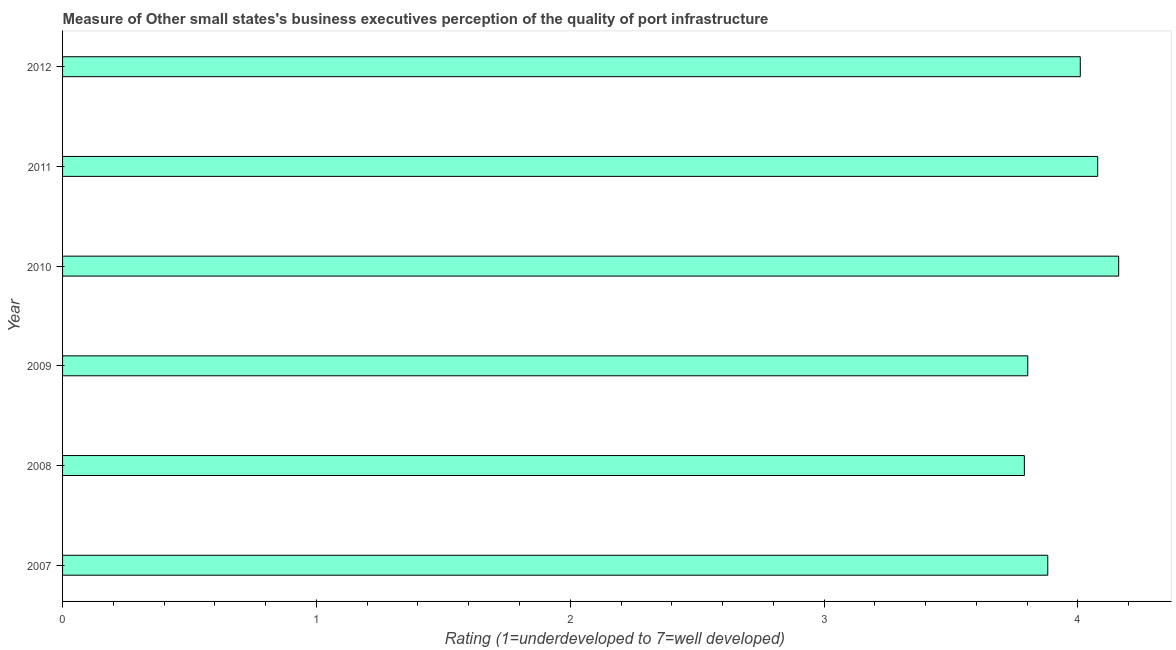What is the title of the graph?
Keep it short and to the point. Measure of Other small states's business executives perception of the quality of port infrastructure. What is the label or title of the X-axis?
Provide a succinct answer. Rating (1=underdeveloped to 7=well developed) . What is the rating measuring quality of port infrastructure in 2010?
Offer a terse response. 4.16. Across all years, what is the maximum rating measuring quality of port infrastructure?
Give a very brief answer. 4.16. Across all years, what is the minimum rating measuring quality of port infrastructure?
Ensure brevity in your answer.  3.79. In which year was the rating measuring quality of port infrastructure maximum?
Offer a very short reply. 2010. What is the sum of the rating measuring quality of port infrastructure?
Ensure brevity in your answer.  23.72. What is the difference between the rating measuring quality of port infrastructure in 2007 and 2012?
Offer a terse response. -0.13. What is the average rating measuring quality of port infrastructure per year?
Give a very brief answer. 3.95. What is the median rating measuring quality of port infrastructure?
Offer a very short reply. 3.95. What is the ratio of the rating measuring quality of port infrastructure in 2009 to that in 2011?
Provide a succinct answer. 0.93. Is the rating measuring quality of port infrastructure in 2010 less than that in 2012?
Ensure brevity in your answer.  No. What is the difference between the highest and the second highest rating measuring quality of port infrastructure?
Keep it short and to the point. 0.08. What is the difference between the highest and the lowest rating measuring quality of port infrastructure?
Give a very brief answer. 0.37. How many bars are there?
Provide a succinct answer. 6. Are all the bars in the graph horizontal?
Provide a short and direct response. Yes. What is the difference between two consecutive major ticks on the X-axis?
Offer a very short reply. 1. What is the Rating (1=underdeveloped to 7=well developed)  in 2007?
Offer a terse response. 3.88. What is the Rating (1=underdeveloped to 7=well developed)  in 2008?
Give a very brief answer. 3.79. What is the Rating (1=underdeveloped to 7=well developed)  in 2009?
Provide a short and direct response. 3.8. What is the Rating (1=underdeveloped to 7=well developed)  of 2010?
Provide a succinct answer. 4.16. What is the Rating (1=underdeveloped to 7=well developed)  in 2011?
Offer a very short reply. 4.08. What is the Rating (1=underdeveloped to 7=well developed)  in 2012?
Ensure brevity in your answer.  4.01. What is the difference between the Rating (1=underdeveloped to 7=well developed)  in 2007 and 2008?
Offer a terse response. 0.09. What is the difference between the Rating (1=underdeveloped to 7=well developed)  in 2007 and 2009?
Give a very brief answer. 0.08. What is the difference between the Rating (1=underdeveloped to 7=well developed)  in 2007 and 2010?
Ensure brevity in your answer.  -0.28. What is the difference between the Rating (1=underdeveloped to 7=well developed)  in 2007 and 2011?
Your answer should be compact. -0.2. What is the difference between the Rating (1=underdeveloped to 7=well developed)  in 2007 and 2012?
Offer a terse response. -0.13. What is the difference between the Rating (1=underdeveloped to 7=well developed)  in 2008 and 2009?
Your answer should be compact. -0.01. What is the difference between the Rating (1=underdeveloped to 7=well developed)  in 2008 and 2010?
Your response must be concise. -0.37. What is the difference between the Rating (1=underdeveloped to 7=well developed)  in 2008 and 2011?
Offer a very short reply. -0.29. What is the difference between the Rating (1=underdeveloped to 7=well developed)  in 2008 and 2012?
Provide a short and direct response. -0.22. What is the difference between the Rating (1=underdeveloped to 7=well developed)  in 2009 and 2010?
Make the answer very short. -0.36. What is the difference between the Rating (1=underdeveloped to 7=well developed)  in 2009 and 2011?
Your answer should be very brief. -0.28. What is the difference between the Rating (1=underdeveloped to 7=well developed)  in 2009 and 2012?
Keep it short and to the point. -0.21. What is the difference between the Rating (1=underdeveloped to 7=well developed)  in 2010 and 2011?
Offer a terse response. 0.08. What is the difference between the Rating (1=underdeveloped to 7=well developed)  in 2010 and 2012?
Offer a terse response. 0.15. What is the difference between the Rating (1=underdeveloped to 7=well developed)  in 2011 and 2012?
Give a very brief answer. 0.07. What is the ratio of the Rating (1=underdeveloped to 7=well developed)  in 2007 to that in 2008?
Make the answer very short. 1.02. What is the ratio of the Rating (1=underdeveloped to 7=well developed)  in 2007 to that in 2009?
Provide a short and direct response. 1.02. What is the ratio of the Rating (1=underdeveloped to 7=well developed)  in 2007 to that in 2010?
Ensure brevity in your answer.  0.93. What is the ratio of the Rating (1=underdeveloped to 7=well developed)  in 2007 to that in 2011?
Make the answer very short. 0.95. What is the ratio of the Rating (1=underdeveloped to 7=well developed)  in 2008 to that in 2009?
Ensure brevity in your answer.  1. What is the ratio of the Rating (1=underdeveloped to 7=well developed)  in 2008 to that in 2010?
Offer a terse response. 0.91. What is the ratio of the Rating (1=underdeveloped to 7=well developed)  in 2008 to that in 2011?
Make the answer very short. 0.93. What is the ratio of the Rating (1=underdeveloped to 7=well developed)  in 2008 to that in 2012?
Your answer should be compact. 0.94. What is the ratio of the Rating (1=underdeveloped to 7=well developed)  in 2009 to that in 2010?
Provide a short and direct response. 0.91. What is the ratio of the Rating (1=underdeveloped to 7=well developed)  in 2009 to that in 2011?
Your answer should be compact. 0.93. What is the ratio of the Rating (1=underdeveloped to 7=well developed)  in 2009 to that in 2012?
Provide a succinct answer. 0.95. What is the ratio of the Rating (1=underdeveloped to 7=well developed)  in 2010 to that in 2011?
Your answer should be compact. 1.02. What is the ratio of the Rating (1=underdeveloped to 7=well developed)  in 2010 to that in 2012?
Your response must be concise. 1.04. What is the ratio of the Rating (1=underdeveloped to 7=well developed)  in 2011 to that in 2012?
Your response must be concise. 1.02. 